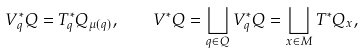<formula> <loc_0><loc_0><loc_500><loc_500>V ^ { \ast } _ { q } Q = T ^ { \ast } _ { q } Q _ { \mu ( q ) } , \quad V ^ { \ast } Q = \bigsqcup _ { q \in Q } V _ { q } ^ { \ast } Q = \bigsqcup _ { x \in M } T ^ { \ast } Q _ { x } ,</formula> 